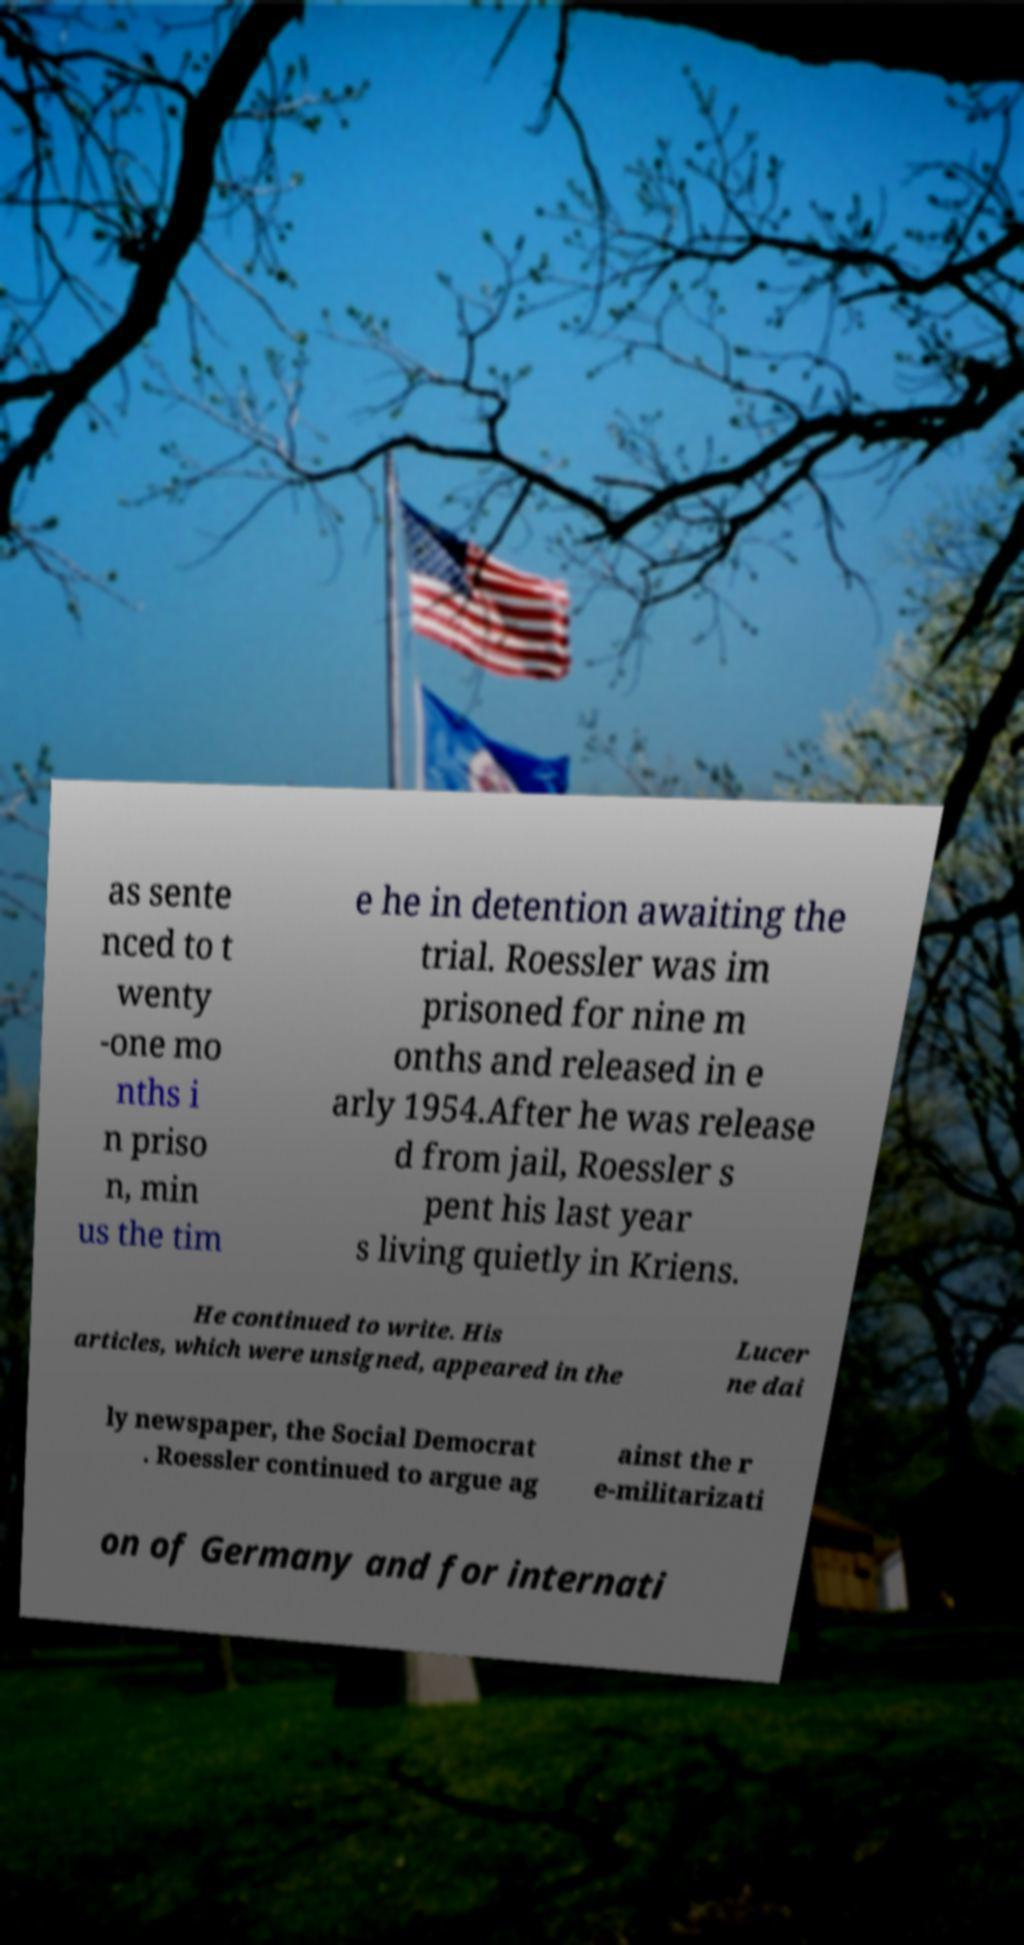What messages or text are displayed in this image? I need them in a readable, typed format. as sente nced to t wenty -one mo nths i n priso n, min us the tim e he in detention awaiting the trial. Roessler was im prisoned for nine m onths and released in e arly 1954.After he was release d from jail, Roessler s pent his last year s living quietly in Kriens. He continued to write. His articles, which were unsigned, appeared in the Lucer ne dai ly newspaper, the Social Democrat . Roessler continued to argue ag ainst the r e-militarizati on of Germany and for internati 